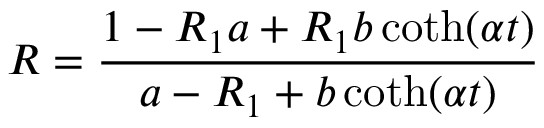<formula> <loc_0><loc_0><loc_500><loc_500>R = \frac { 1 - R _ { 1 } a + R _ { 1 } b \coth ( \alpha t ) } { a - R _ { 1 } + b \coth ( \alpha t ) }</formula> 